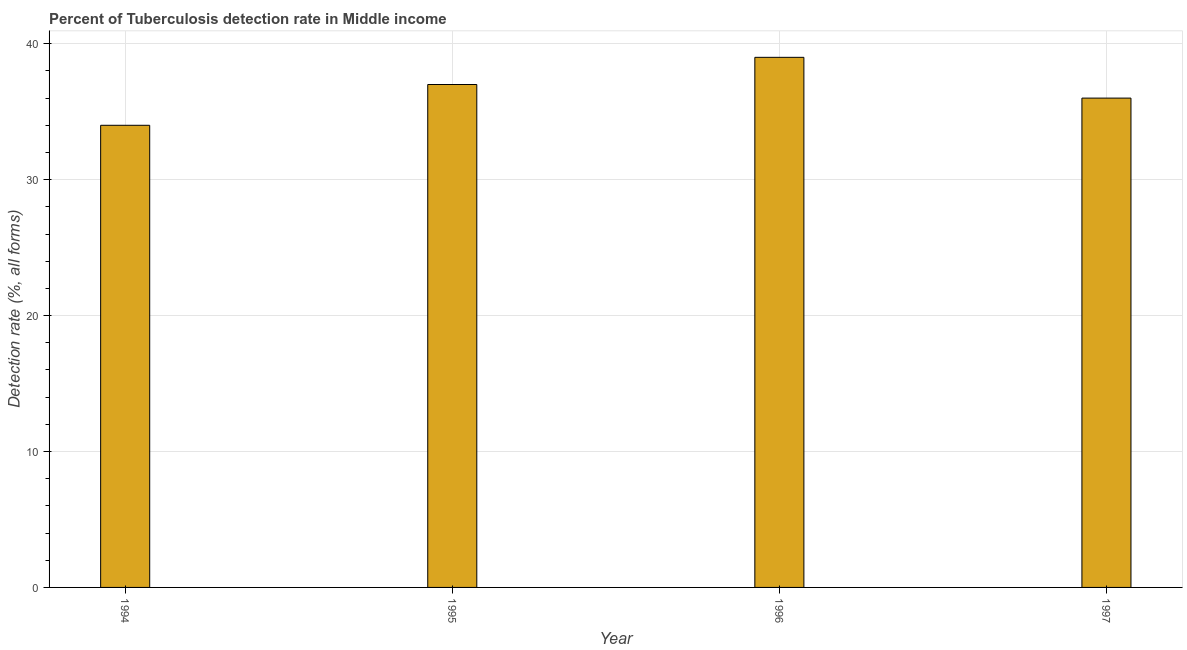Does the graph contain any zero values?
Offer a terse response. No. What is the title of the graph?
Provide a short and direct response. Percent of Tuberculosis detection rate in Middle income. What is the label or title of the Y-axis?
Your response must be concise. Detection rate (%, all forms). What is the detection rate of tuberculosis in 1996?
Make the answer very short. 39. Across all years, what is the minimum detection rate of tuberculosis?
Make the answer very short. 34. In which year was the detection rate of tuberculosis minimum?
Offer a very short reply. 1994. What is the sum of the detection rate of tuberculosis?
Give a very brief answer. 146. What is the median detection rate of tuberculosis?
Your answer should be compact. 36.5. Do a majority of the years between 1997 and 1996 (inclusive) have detection rate of tuberculosis greater than 20 %?
Offer a terse response. No. What is the ratio of the detection rate of tuberculosis in 1996 to that in 1997?
Give a very brief answer. 1.08. Is the difference between the detection rate of tuberculosis in 1994 and 1995 greater than the difference between any two years?
Your response must be concise. No. What is the difference between the highest and the second highest detection rate of tuberculosis?
Provide a succinct answer. 2. What is the difference between the highest and the lowest detection rate of tuberculosis?
Offer a very short reply. 5. In how many years, is the detection rate of tuberculosis greater than the average detection rate of tuberculosis taken over all years?
Give a very brief answer. 2. Are all the bars in the graph horizontal?
Make the answer very short. No. What is the difference between two consecutive major ticks on the Y-axis?
Provide a short and direct response. 10. What is the Detection rate (%, all forms) of 1995?
Provide a succinct answer. 37. What is the Detection rate (%, all forms) in 1996?
Provide a succinct answer. 39. What is the Detection rate (%, all forms) in 1997?
Ensure brevity in your answer.  36. What is the difference between the Detection rate (%, all forms) in 1994 and 1996?
Give a very brief answer. -5. What is the difference between the Detection rate (%, all forms) in 1995 and 1996?
Keep it short and to the point. -2. What is the difference between the Detection rate (%, all forms) in 1995 and 1997?
Your answer should be compact. 1. What is the ratio of the Detection rate (%, all forms) in 1994 to that in 1995?
Your answer should be compact. 0.92. What is the ratio of the Detection rate (%, all forms) in 1994 to that in 1996?
Your answer should be compact. 0.87. What is the ratio of the Detection rate (%, all forms) in 1994 to that in 1997?
Offer a very short reply. 0.94. What is the ratio of the Detection rate (%, all forms) in 1995 to that in 1996?
Offer a very short reply. 0.95. What is the ratio of the Detection rate (%, all forms) in 1995 to that in 1997?
Give a very brief answer. 1.03. What is the ratio of the Detection rate (%, all forms) in 1996 to that in 1997?
Give a very brief answer. 1.08. 